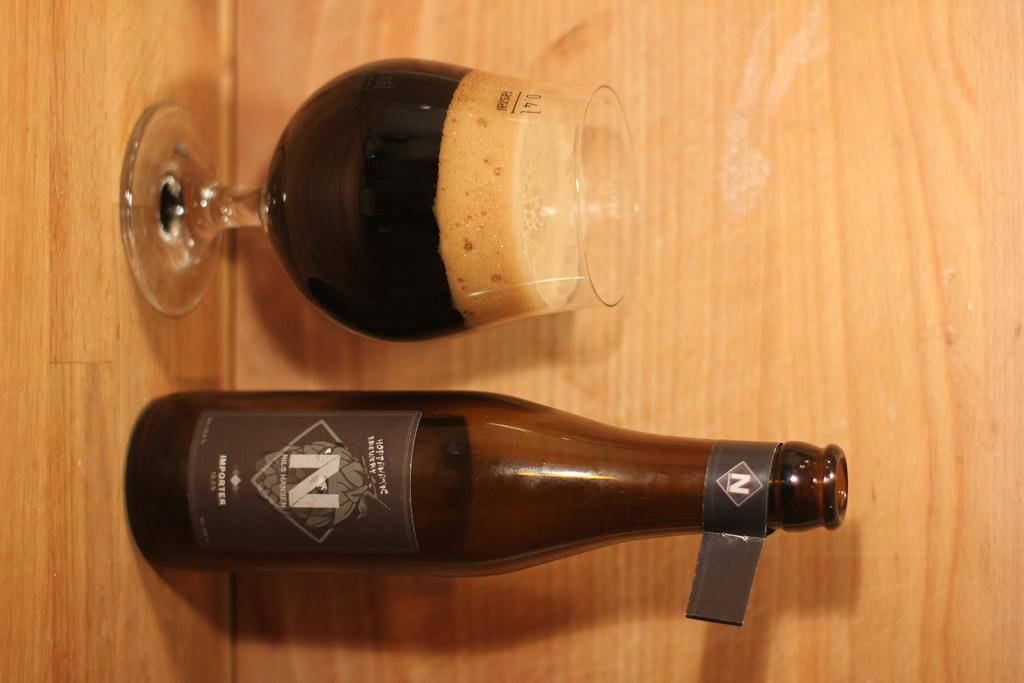Provide a one-sentence caption for the provided image. N Importer beer with mostly full snifter next to it with foam at the top. 